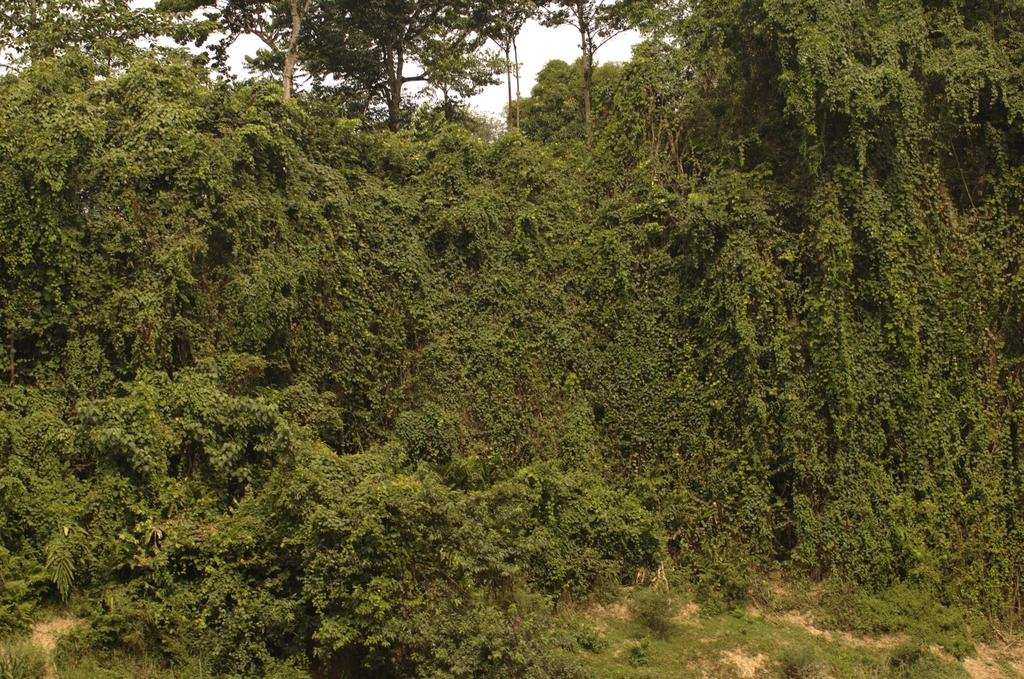What type of vegetation can be seen in the image? There are trees and plants in the image. What part of the natural environment is visible in the image? The sky is visible in the background of the image. How many pigs are visible in the image? There are no pigs present in the image. What type of container is being used to hold the stomach in the image? There is no stomach or container present in the image. 